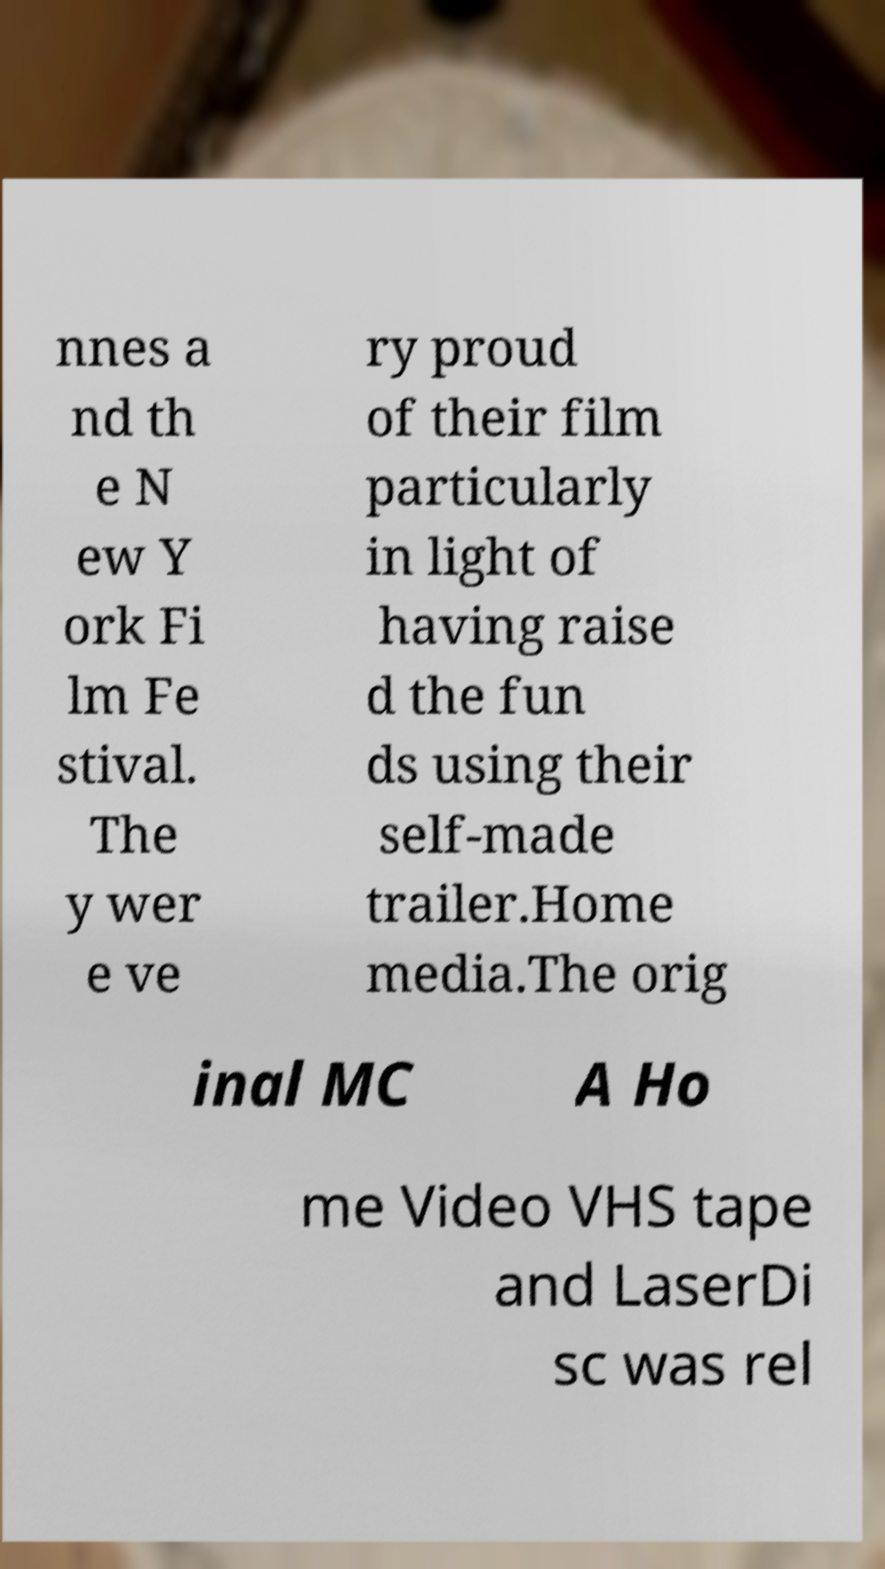Could you extract and type out the text from this image? nnes a nd th e N ew Y ork Fi lm Fe stival. The y wer e ve ry proud of their film particularly in light of having raise d the fun ds using their self-made trailer.Home media.The orig inal MC A Ho me Video VHS tape and LaserDi sc was rel 